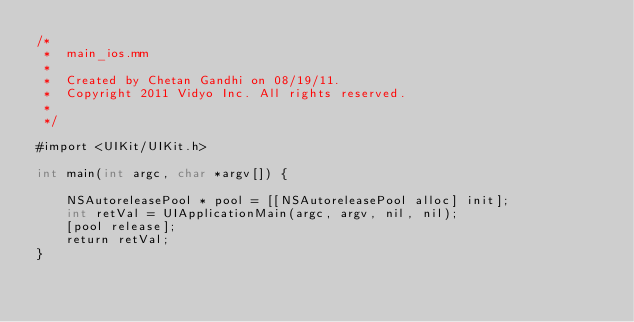Convert code to text. <code><loc_0><loc_0><loc_500><loc_500><_ObjectiveC_>/*
 *  main_ios.mm
 *
 *  Created by Chetan Gandhi on 08/19/11.
 *  Copyright 2011 Vidyo Inc. All rights reserved.
 *
 */

#import <UIKit/UIKit.h>

int main(int argc, char *argv[]) {
    
    NSAutoreleasePool * pool = [[NSAutoreleasePool alloc] init];
    int retVal = UIApplicationMain(argc, argv, nil, nil);
    [pool release];
    return retVal;
}
</code> 